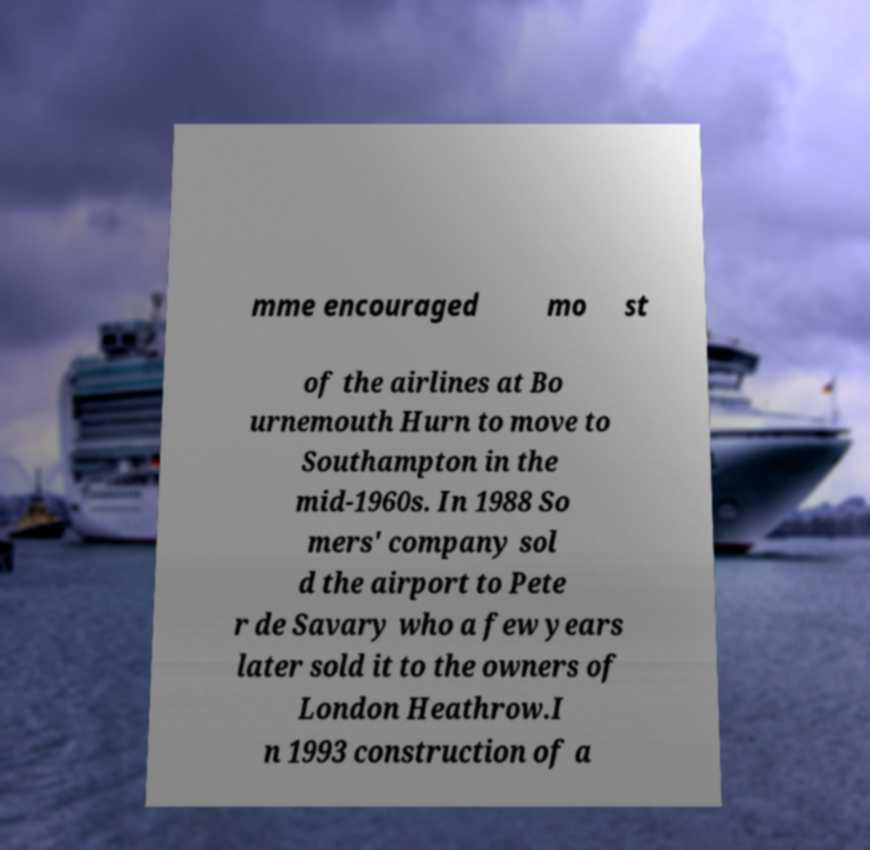Can you accurately transcribe the text from the provided image for me? mme encouraged mo st of the airlines at Bo urnemouth Hurn to move to Southampton in the mid-1960s. In 1988 So mers' company sol d the airport to Pete r de Savary who a few years later sold it to the owners of London Heathrow.I n 1993 construction of a 